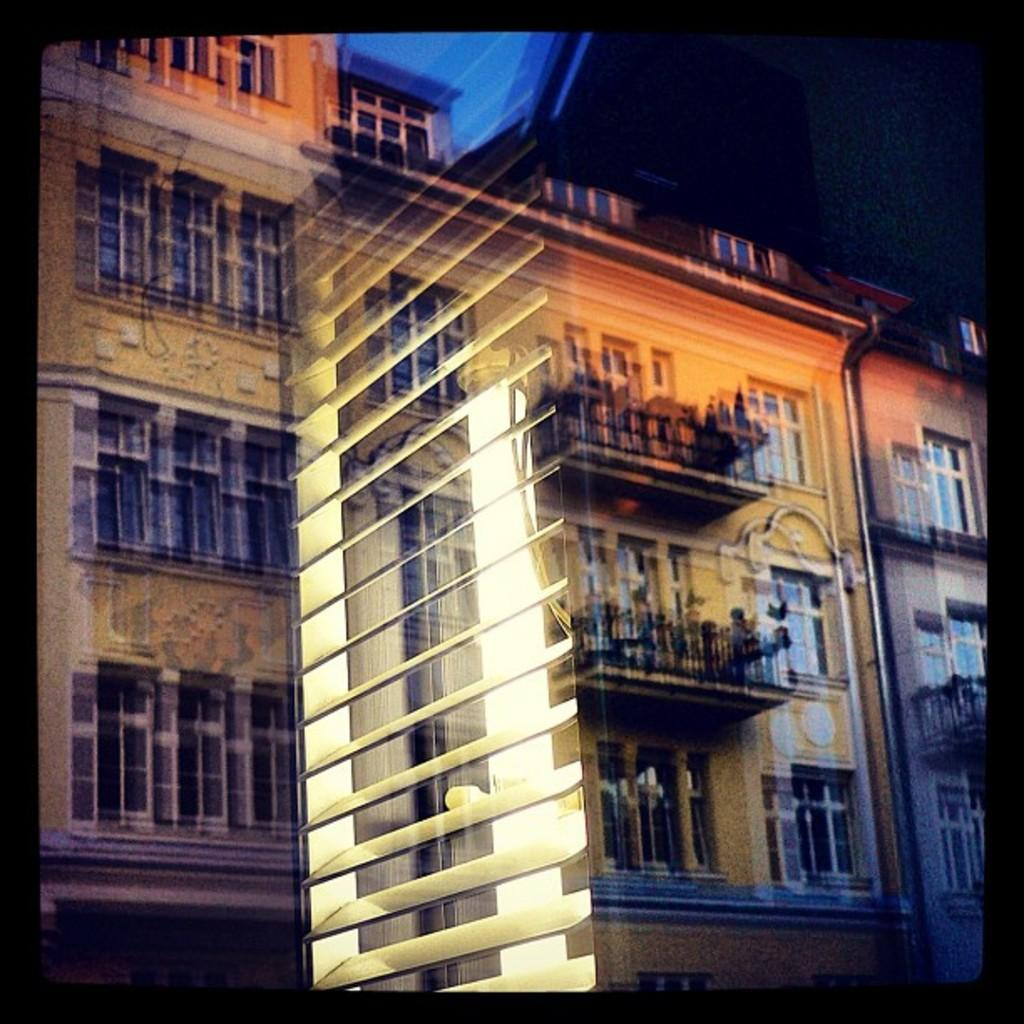What architectural features can be seen in the image? There are windows, railings, and lights visible in the image. What type of vegetation is present in the image? There are plants in the image. What structure are these elements associated with? These elements are associated with a building. What type of meat is being cooked on the grill in the image? There is no grill or meat present in the image. 